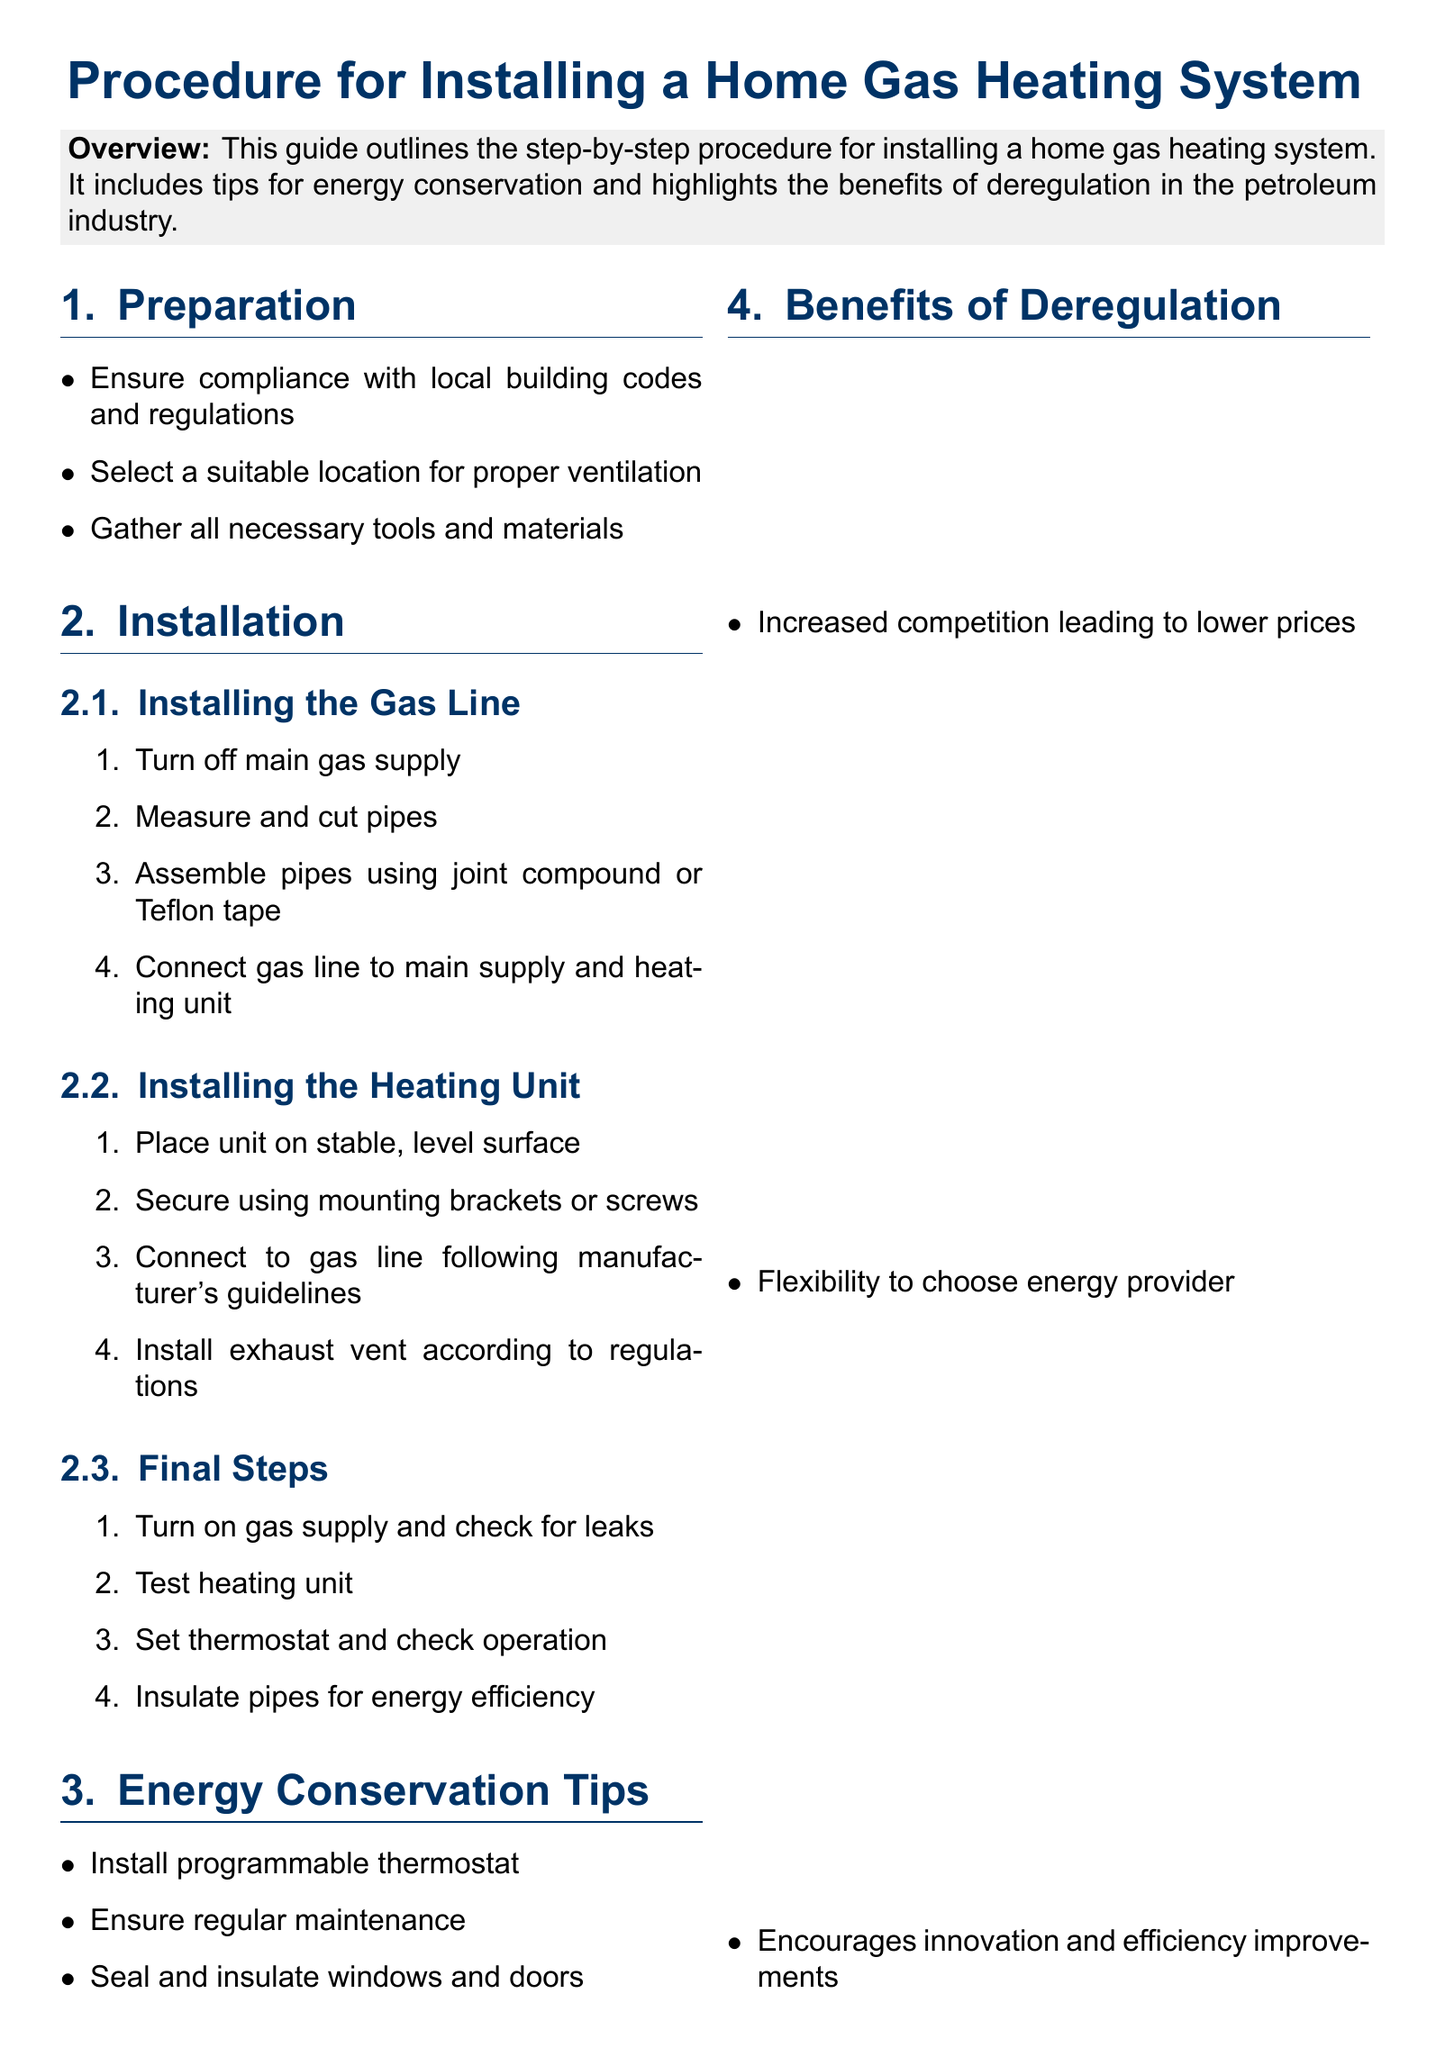What is the first step in preparation? The first step listed under preparation is to ensure compliance with local building codes and regulations.
Answer: Ensure compliance with local building codes and regulations How many steps are outlined for installing the gas line? There are four steps listed under the installation of the gas line.
Answer: Four What do you need to do to the pipes for insulation? The document suggests insulating pipes for energy efficiency.
Answer: Insulate pipes What type of thermostat is recommended for energy conservation? The document recommends installing a programmable thermostat for better energy efficiency.
Answer: Programmable thermostat What benefit of deregulation is mentioned related to prices? Increased competition leading to lower prices is highlighted as a benefit of deregulation.
Answer: Lower prices How should the heating unit be secured? The heating unit should be secured using mounting brackets or screws.
Answer: Mounting brackets or screws What is the purpose of installing an exhaust vent? Installing an exhaust vent is necessary according to regulations during the installation process.
Answer: According to regulations How many energy conservation tips are listed in the document? The document lists three energy conservation tips.
Answer: Three What does the final note in the document recommend for homeowners? The note strongly recommends taking advantage of the benefits that deregulation brings to homeowners.
Answer: Taking advantage of the benefits What is the importance of sealing and insulating windows and doors? Sealing and insulating windows and doors helps in conserving energy.
Answer: Energy conservation 